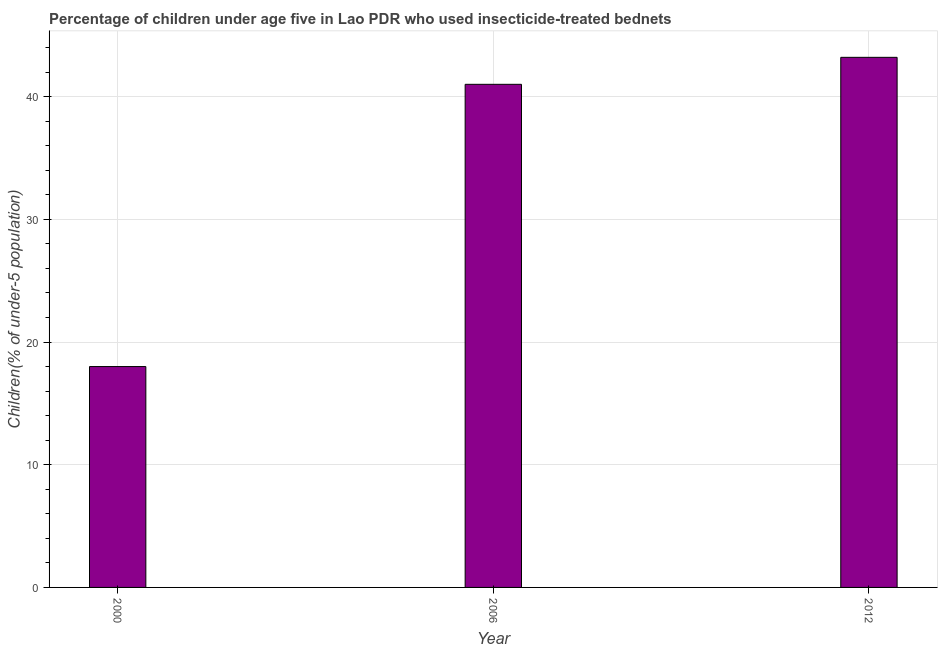Does the graph contain grids?
Your answer should be compact. Yes. What is the title of the graph?
Provide a short and direct response. Percentage of children under age five in Lao PDR who used insecticide-treated bednets. What is the label or title of the Y-axis?
Offer a very short reply. Children(% of under-5 population). Across all years, what is the maximum percentage of children who use of insecticide-treated bed nets?
Keep it short and to the point. 43.2. Across all years, what is the minimum percentage of children who use of insecticide-treated bed nets?
Offer a very short reply. 18. In which year was the percentage of children who use of insecticide-treated bed nets maximum?
Your answer should be very brief. 2012. In which year was the percentage of children who use of insecticide-treated bed nets minimum?
Keep it short and to the point. 2000. What is the sum of the percentage of children who use of insecticide-treated bed nets?
Make the answer very short. 102.2. What is the difference between the percentage of children who use of insecticide-treated bed nets in 2000 and 2012?
Give a very brief answer. -25.2. What is the average percentage of children who use of insecticide-treated bed nets per year?
Your response must be concise. 34.07. What is the median percentage of children who use of insecticide-treated bed nets?
Keep it short and to the point. 41. In how many years, is the percentage of children who use of insecticide-treated bed nets greater than 12 %?
Your response must be concise. 3. What is the ratio of the percentage of children who use of insecticide-treated bed nets in 2006 to that in 2012?
Give a very brief answer. 0.95. Is the percentage of children who use of insecticide-treated bed nets in 2006 less than that in 2012?
Give a very brief answer. Yes. Is the difference between the percentage of children who use of insecticide-treated bed nets in 2006 and 2012 greater than the difference between any two years?
Your answer should be very brief. No. What is the difference between the highest and the second highest percentage of children who use of insecticide-treated bed nets?
Make the answer very short. 2.2. What is the difference between the highest and the lowest percentage of children who use of insecticide-treated bed nets?
Your answer should be compact. 25.2. In how many years, is the percentage of children who use of insecticide-treated bed nets greater than the average percentage of children who use of insecticide-treated bed nets taken over all years?
Your response must be concise. 2. How many years are there in the graph?
Your answer should be very brief. 3. What is the difference between two consecutive major ticks on the Y-axis?
Provide a succinct answer. 10. What is the Children(% of under-5 population) of 2000?
Ensure brevity in your answer.  18. What is the Children(% of under-5 population) in 2006?
Ensure brevity in your answer.  41. What is the Children(% of under-5 population) in 2012?
Your answer should be very brief. 43.2. What is the difference between the Children(% of under-5 population) in 2000 and 2012?
Ensure brevity in your answer.  -25.2. What is the ratio of the Children(% of under-5 population) in 2000 to that in 2006?
Give a very brief answer. 0.44. What is the ratio of the Children(% of under-5 population) in 2000 to that in 2012?
Offer a terse response. 0.42. What is the ratio of the Children(% of under-5 population) in 2006 to that in 2012?
Your answer should be compact. 0.95. 